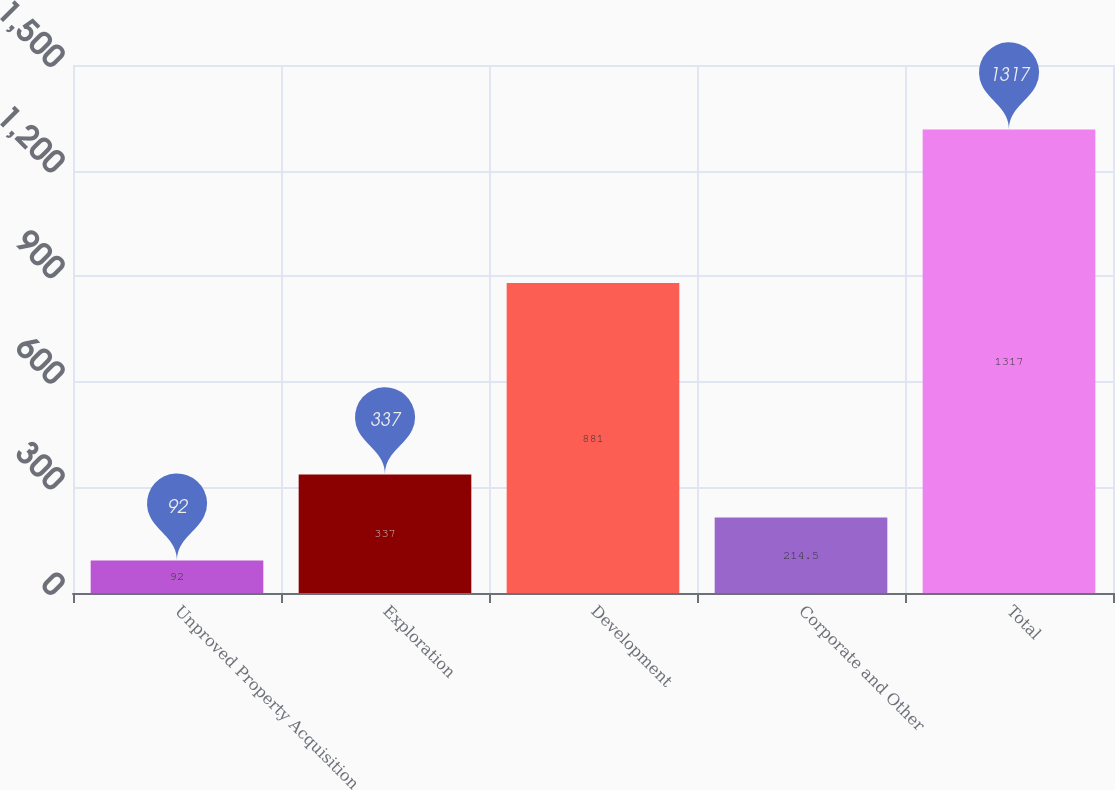<chart> <loc_0><loc_0><loc_500><loc_500><bar_chart><fcel>Unproved Property Acquisition<fcel>Exploration<fcel>Development<fcel>Corporate and Other<fcel>Total<nl><fcel>92<fcel>337<fcel>881<fcel>214.5<fcel>1317<nl></chart> 